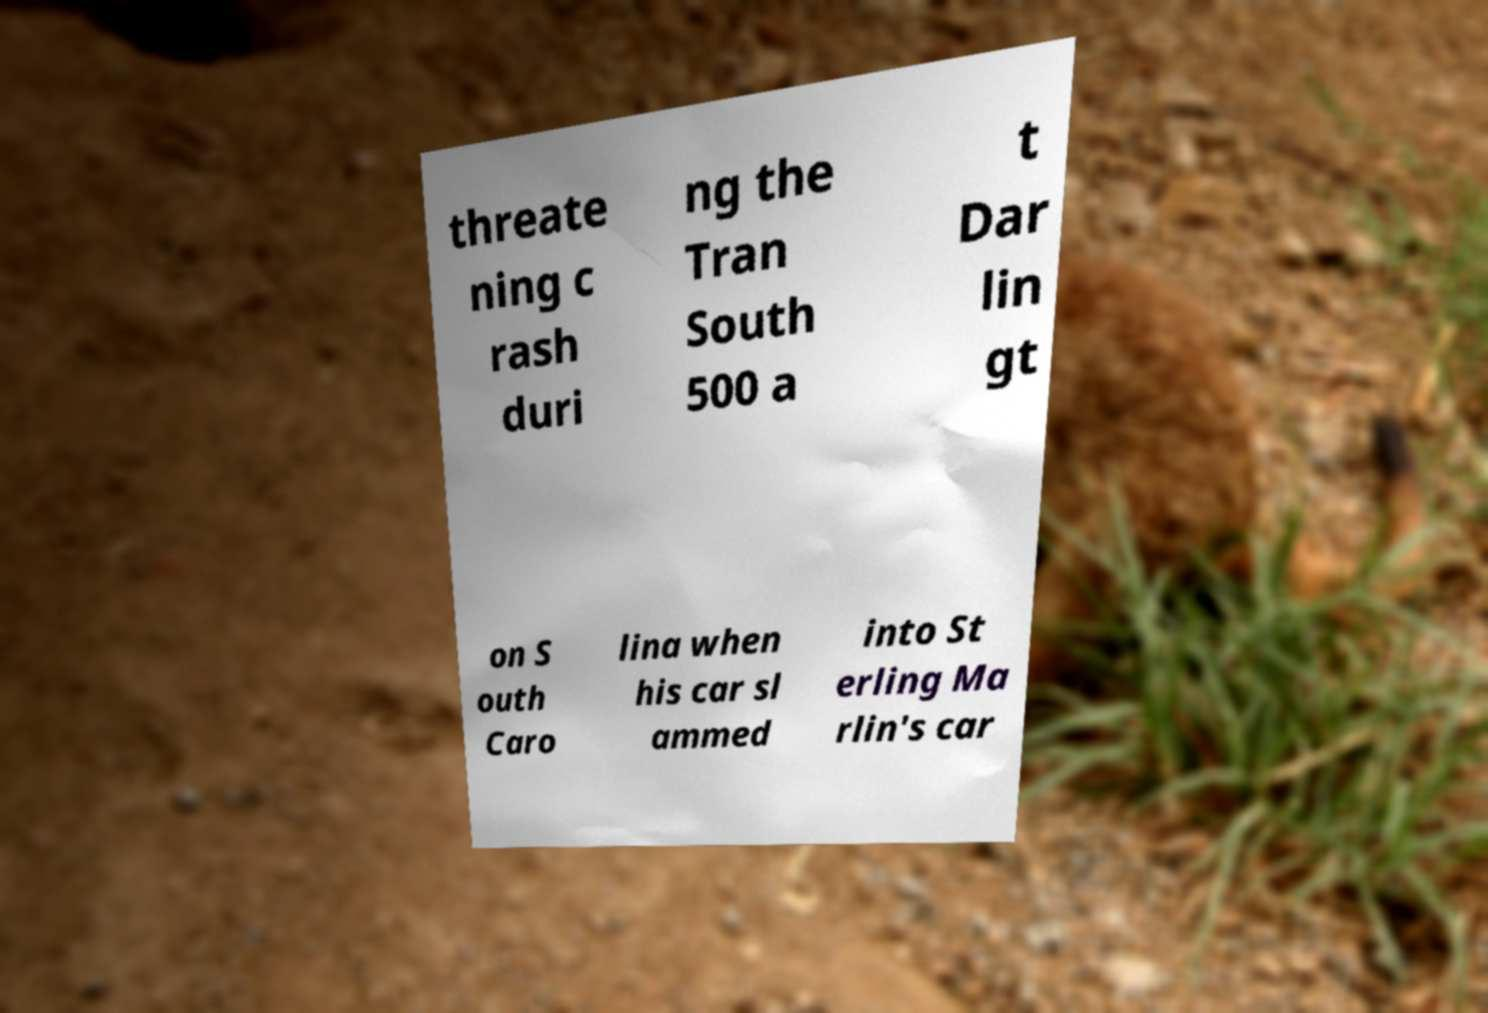There's text embedded in this image that I need extracted. Can you transcribe it verbatim? threate ning c rash duri ng the Tran South 500 a t Dar lin gt on S outh Caro lina when his car sl ammed into St erling Ma rlin's car 